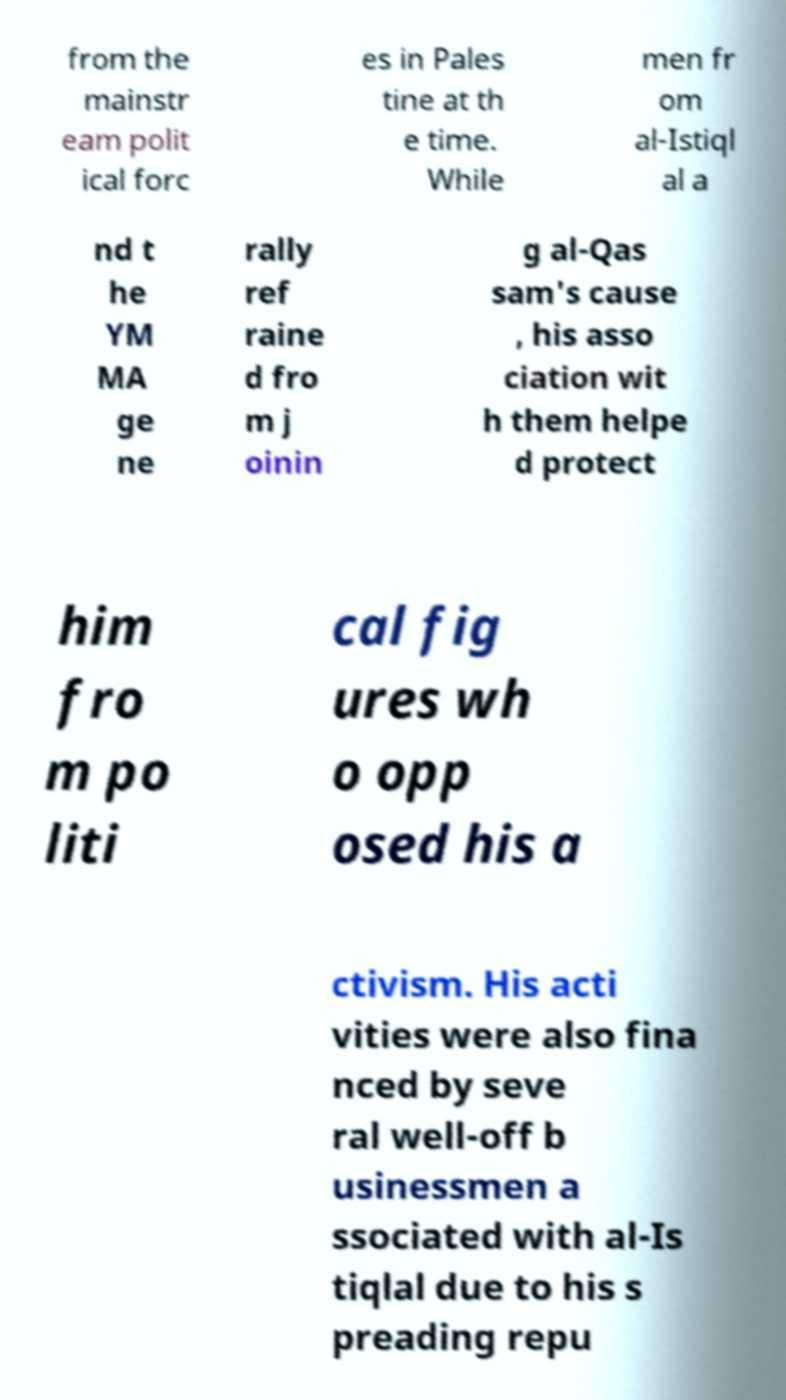Could you assist in decoding the text presented in this image and type it out clearly? from the mainstr eam polit ical forc es in Pales tine at th e time. While men fr om al-Istiql al a nd t he YM MA ge ne rally ref raine d fro m j oinin g al-Qas sam's cause , his asso ciation wit h them helpe d protect him fro m po liti cal fig ures wh o opp osed his a ctivism. His acti vities were also fina nced by seve ral well-off b usinessmen a ssociated with al-Is tiqlal due to his s preading repu 